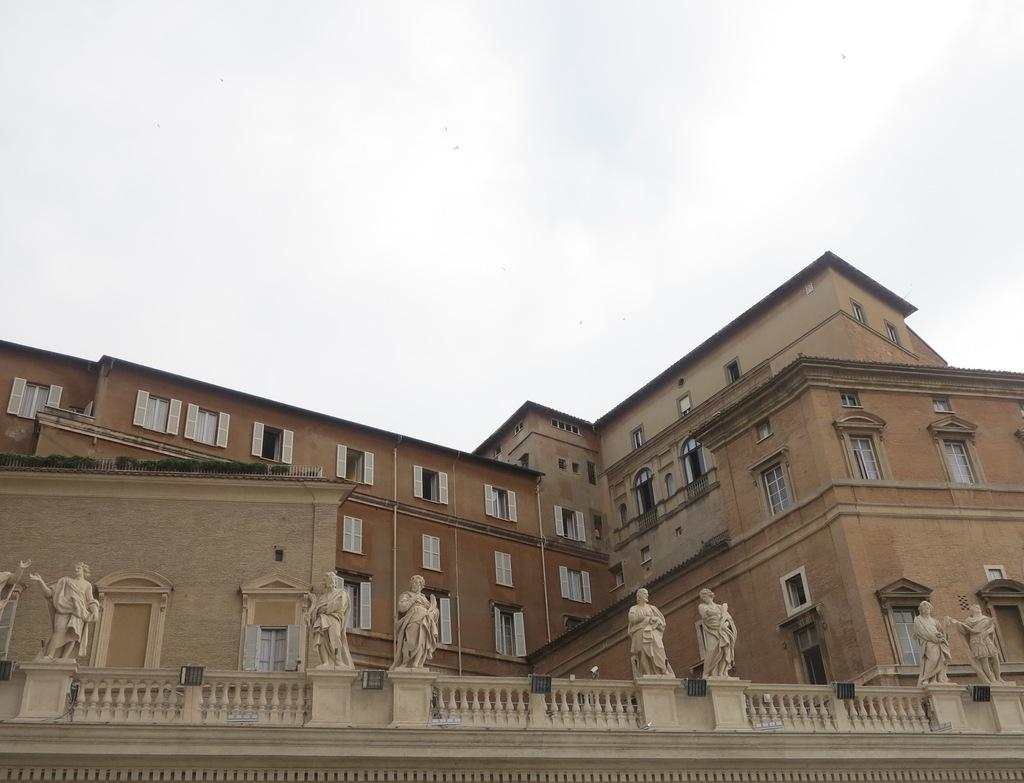What type of structures can be seen in the image? There are buildings in the image. What other elements are present in the image besides buildings? There are plants, an iron grill, pipelines, and statues on the wall in the image. What can be seen in the background of the image? The sky is visible in the background of the image. How many children are playing with the elbow in the image? There are no children or elbows present in the image. 